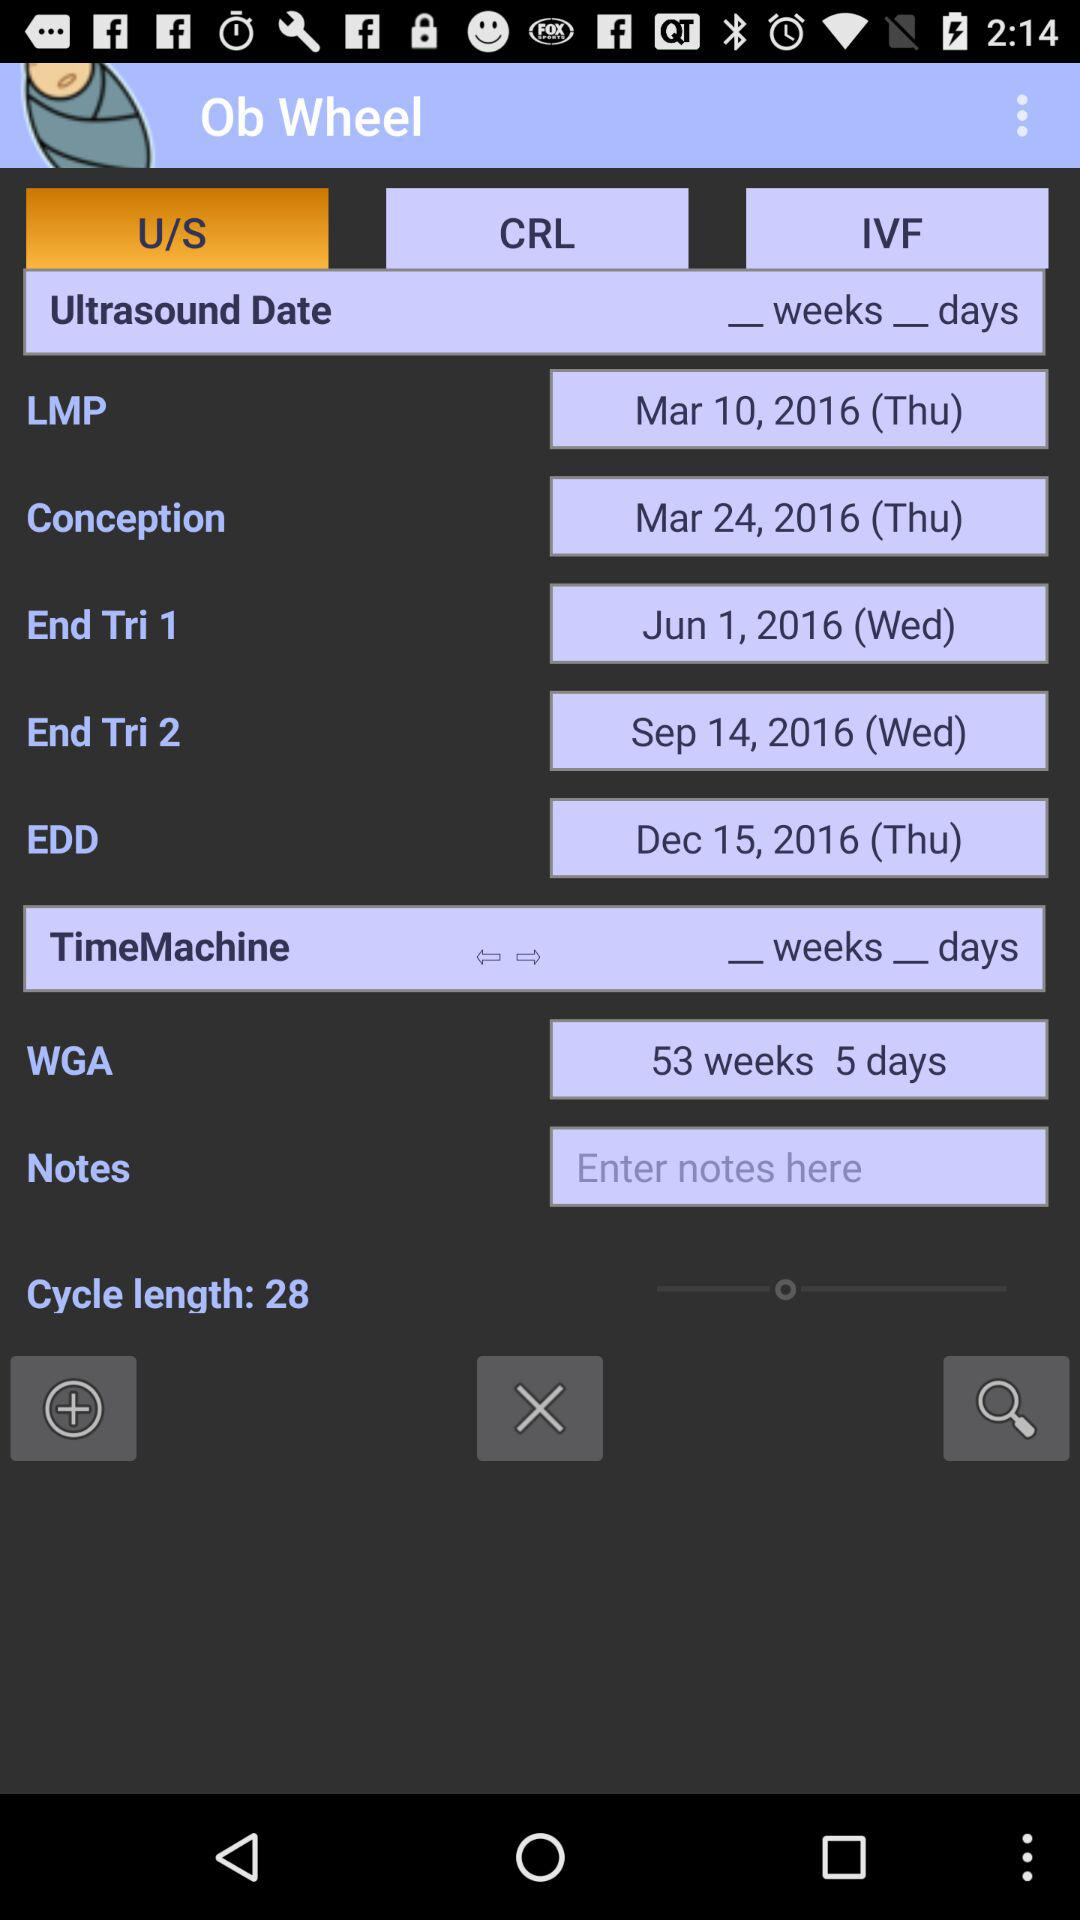How many days apart are the LMP and Conception dates? 14 days 